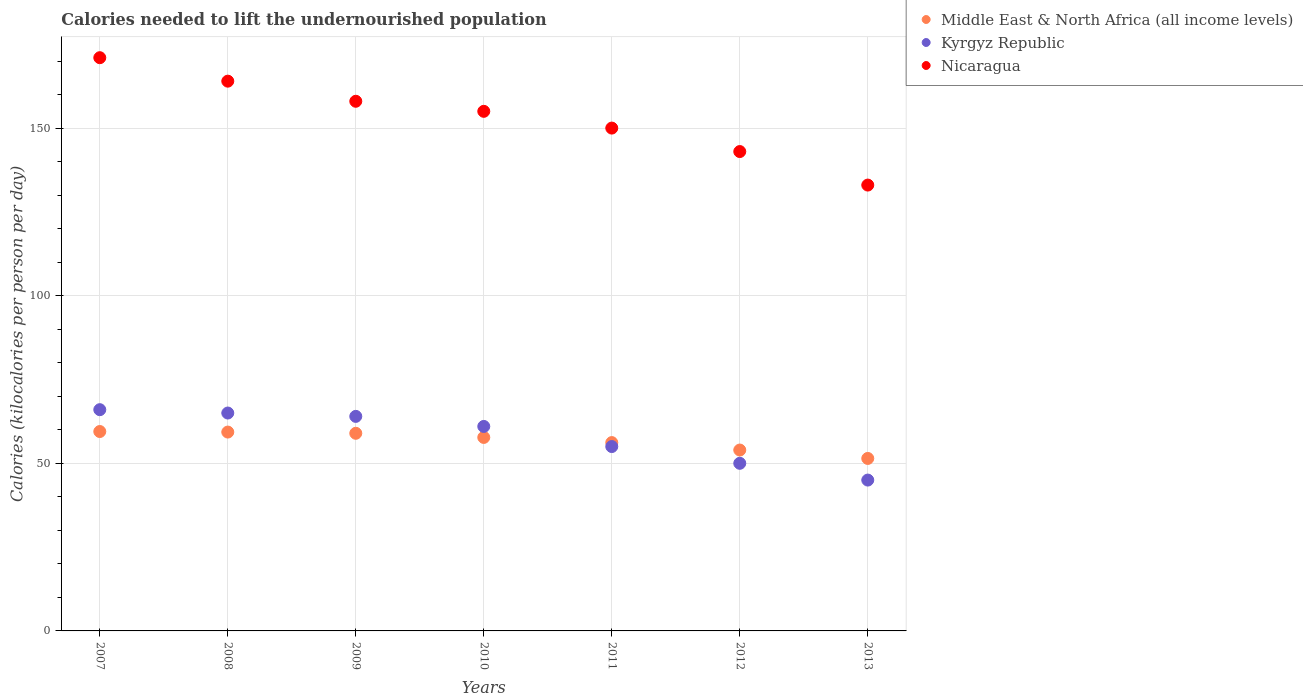How many different coloured dotlines are there?
Make the answer very short. 3. What is the total calories needed to lift the undernourished population in Middle East & North Africa (all income levels) in 2011?
Your answer should be very brief. 56.18. Across all years, what is the maximum total calories needed to lift the undernourished population in Kyrgyz Republic?
Give a very brief answer. 66. Across all years, what is the minimum total calories needed to lift the undernourished population in Nicaragua?
Offer a very short reply. 133. In which year was the total calories needed to lift the undernourished population in Kyrgyz Republic maximum?
Your answer should be very brief. 2007. What is the total total calories needed to lift the undernourished population in Nicaragua in the graph?
Your response must be concise. 1074. What is the difference between the total calories needed to lift the undernourished population in Middle East & North Africa (all income levels) in 2007 and that in 2010?
Ensure brevity in your answer.  1.76. What is the difference between the total calories needed to lift the undernourished population in Nicaragua in 2013 and the total calories needed to lift the undernourished population in Middle East & North Africa (all income levels) in 2010?
Provide a short and direct response. 75.28. What is the average total calories needed to lift the undernourished population in Kyrgyz Republic per year?
Your response must be concise. 58. In the year 2010, what is the difference between the total calories needed to lift the undernourished population in Nicaragua and total calories needed to lift the undernourished population in Kyrgyz Republic?
Provide a succinct answer. 94. In how many years, is the total calories needed to lift the undernourished population in Nicaragua greater than 130 kilocalories?
Provide a succinct answer. 7. What is the ratio of the total calories needed to lift the undernourished population in Nicaragua in 2010 to that in 2011?
Make the answer very short. 1.03. What is the difference between the highest and the lowest total calories needed to lift the undernourished population in Nicaragua?
Your answer should be compact. 38. In how many years, is the total calories needed to lift the undernourished population in Middle East & North Africa (all income levels) greater than the average total calories needed to lift the undernourished population in Middle East & North Africa (all income levels) taken over all years?
Offer a terse response. 4. Is the sum of the total calories needed to lift the undernourished population in Nicaragua in 2007 and 2009 greater than the maximum total calories needed to lift the undernourished population in Middle East & North Africa (all income levels) across all years?
Your answer should be very brief. Yes. Does the total calories needed to lift the undernourished population in Nicaragua monotonically increase over the years?
Provide a short and direct response. No. Is the total calories needed to lift the undernourished population in Kyrgyz Republic strictly less than the total calories needed to lift the undernourished population in Middle East & North Africa (all income levels) over the years?
Your answer should be very brief. No. How many years are there in the graph?
Offer a terse response. 7. Does the graph contain any zero values?
Offer a terse response. No. Does the graph contain grids?
Provide a short and direct response. Yes. Where does the legend appear in the graph?
Keep it short and to the point. Top right. What is the title of the graph?
Provide a short and direct response. Calories needed to lift the undernourished population. Does "Middle income" appear as one of the legend labels in the graph?
Provide a succinct answer. No. What is the label or title of the Y-axis?
Provide a short and direct response. Calories (kilocalories per person per day). What is the Calories (kilocalories per person per day) in Middle East & North Africa (all income levels) in 2007?
Ensure brevity in your answer.  59.48. What is the Calories (kilocalories per person per day) of Kyrgyz Republic in 2007?
Make the answer very short. 66. What is the Calories (kilocalories per person per day) in Nicaragua in 2007?
Ensure brevity in your answer.  171. What is the Calories (kilocalories per person per day) of Middle East & North Africa (all income levels) in 2008?
Provide a succinct answer. 59.32. What is the Calories (kilocalories per person per day) in Nicaragua in 2008?
Keep it short and to the point. 164. What is the Calories (kilocalories per person per day) of Middle East & North Africa (all income levels) in 2009?
Offer a terse response. 58.95. What is the Calories (kilocalories per person per day) in Nicaragua in 2009?
Your response must be concise. 158. What is the Calories (kilocalories per person per day) of Middle East & North Africa (all income levels) in 2010?
Make the answer very short. 57.72. What is the Calories (kilocalories per person per day) of Kyrgyz Republic in 2010?
Provide a succinct answer. 61. What is the Calories (kilocalories per person per day) in Nicaragua in 2010?
Make the answer very short. 155. What is the Calories (kilocalories per person per day) of Middle East & North Africa (all income levels) in 2011?
Your answer should be very brief. 56.18. What is the Calories (kilocalories per person per day) in Nicaragua in 2011?
Make the answer very short. 150. What is the Calories (kilocalories per person per day) of Middle East & North Africa (all income levels) in 2012?
Give a very brief answer. 53.96. What is the Calories (kilocalories per person per day) of Kyrgyz Republic in 2012?
Ensure brevity in your answer.  50. What is the Calories (kilocalories per person per day) of Nicaragua in 2012?
Keep it short and to the point. 143. What is the Calories (kilocalories per person per day) in Middle East & North Africa (all income levels) in 2013?
Give a very brief answer. 51.45. What is the Calories (kilocalories per person per day) of Nicaragua in 2013?
Your answer should be very brief. 133. Across all years, what is the maximum Calories (kilocalories per person per day) of Middle East & North Africa (all income levels)?
Ensure brevity in your answer.  59.48. Across all years, what is the maximum Calories (kilocalories per person per day) in Nicaragua?
Provide a succinct answer. 171. Across all years, what is the minimum Calories (kilocalories per person per day) of Middle East & North Africa (all income levels)?
Offer a terse response. 51.45. Across all years, what is the minimum Calories (kilocalories per person per day) of Kyrgyz Republic?
Provide a succinct answer. 45. Across all years, what is the minimum Calories (kilocalories per person per day) of Nicaragua?
Provide a succinct answer. 133. What is the total Calories (kilocalories per person per day) of Middle East & North Africa (all income levels) in the graph?
Offer a very short reply. 397.07. What is the total Calories (kilocalories per person per day) of Kyrgyz Republic in the graph?
Provide a succinct answer. 406. What is the total Calories (kilocalories per person per day) in Nicaragua in the graph?
Offer a very short reply. 1074. What is the difference between the Calories (kilocalories per person per day) of Middle East & North Africa (all income levels) in 2007 and that in 2008?
Ensure brevity in your answer.  0.16. What is the difference between the Calories (kilocalories per person per day) in Kyrgyz Republic in 2007 and that in 2008?
Offer a very short reply. 1. What is the difference between the Calories (kilocalories per person per day) of Middle East & North Africa (all income levels) in 2007 and that in 2009?
Your answer should be compact. 0.53. What is the difference between the Calories (kilocalories per person per day) of Nicaragua in 2007 and that in 2009?
Ensure brevity in your answer.  13. What is the difference between the Calories (kilocalories per person per day) of Middle East & North Africa (all income levels) in 2007 and that in 2010?
Make the answer very short. 1.76. What is the difference between the Calories (kilocalories per person per day) of Kyrgyz Republic in 2007 and that in 2010?
Keep it short and to the point. 5. What is the difference between the Calories (kilocalories per person per day) in Nicaragua in 2007 and that in 2010?
Make the answer very short. 16. What is the difference between the Calories (kilocalories per person per day) in Middle East & North Africa (all income levels) in 2007 and that in 2011?
Provide a short and direct response. 3.3. What is the difference between the Calories (kilocalories per person per day) in Nicaragua in 2007 and that in 2011?
Provide a succinct answer. 21. What is the difference between the Calories (kilocalories per person per day) of Middle East & North Africa (all income levels) in 2007 and that in 2012?
Offer a very short reply. 5.53. What is the difference between the Calories (kilocalories per person per day) in Middle East & North Africa (all income levels) in 2007 and that in 2013?
Your answer should be very brief. 8.03. What is the difference between the Calories (kilocalories per person per day) in Kyrgyz Republic in 2007 and that in 2013?
Offer a very short reply. 21. What is the difference between the Calories (kilocalories per person per day) of Nicaragua in 2007 and that in 2013?
Your response must be concise. 38. What is the difference between the Calories (kilocalories per person per day) of Middle East & North Africa (all income levels) in 2008 and that in 2009?
Give a very brief answer. 0.37. What is the difference between the Calories (kilocalories per person per day) of Kyrgyz Republic in 2008 and that in 2009?
Your answer should be very brief. 1. What is the difference between the Calories (kilocalories per person per day) in Nicaragua in 2008 and that in 2009?
Your response must be concise. 6. What is the difference between the Calories (kilocalories per person per day) of Middle East & North Africa (all income levels) in 2008 and that in 2010?
Your answer should be very brief. 1.6. What is the difference between the Calories (kilocalories per person per day) of Kyrgyz Republic in 2008 and that in 2010?
Your answer should be very brief. 4. What is the difference between the Calories (kilocalories per person per day) in Nicaragua in 2008 and that in 2010?
Offer a terse response. 9. What is the difference between the Calories (kilocalories per person per day) in Middle East & North Africa (all income levels) in 2008 and that in 2011?
Ensure brevity in your answer.  3.14. What is the difference between the Calories (kilocalories per person per day) in Nicaragua in 2008 and that in 2011?
Ensure brevity in your answer.  14. What is the difference between the Calories (kilocalories per person per day) in Middle East & North Africa (all income levels) in 2008 and that in 2012?
Offer a very short reply. 5.36. What is the difference between the Calories (kilocalories per person per day) of Kyrgyz Republic in 2008 and that in 2012?
Your answer should be very brief. 15. What is the difference between the Calories (kilocalories per person per day) of Nicaragua in 2008 and that in 2012?
Ensure brevity in your answer.  21. What is the difference between the Calories (kilocalories per person per day) in Middle East & North Africa (all income levels) in 2008 and that in 2013?
Provide a succinct answer. 7.87. What is the difference between the Calories (kilocalories per person per day) of Middle East & North Africa (all income levels) in 2009 and that in 2010?
Your answer should be compact. 1.23. What is the difference between the Calories (kilocalories per person per day) in Middle East & North Africa (all income levels) in 2009 and that in 2011?
Make the answer very short. 2.77. What is the difference between the Calories (kilocalories per person per day) of Middle East & North Africa (all income levels) in 2009 and that in 2012?
Give a very brief answer. 5. What is the difference between the Calories (kilocalories per person per day) in Middle East & North Africa (all income levels) in 2009 and that in 2013?
Your answer should be very brief. 7.5. What is the difference between the Calories (kilocalories per person per day) of Kyrgyz Republic in 2009 and that in 2013?
Your answer should be very brief. 19. What is the difference between the Calories (kilocalories per person per day) in Nicaragua in 2009 and that in 2013?
Provide a succinct answer. 25. What is the difference between the Calories (kilocalories per person per day) in Middle East & North Africa (all income levels) in 2010 and that in 2011?
Give a very brief answer. 1.54. What is the difference between the Calories (kilocalories per person per day) in Nicaragua in 2010 and that in 2011?
Offer a terse response. 5. What is the difference between the Calories (kilocalories per person per day) in Middle East & North Africa (all income levels) in 2010 and that in 2012?
Offer a very short reply. 3.76. What is the difference between the Calories (kilocalories per person per day) of Nicaragua in 2010 and that in 2012?
Offer a terse response. 12. What is the difference between the Calories (kilocalories per person per day) in Middle East & North Africa (all income levels) in 2010 and that in 2013?
Your answer should be compact. 6.27. What is the difference between the Calories (kilocalories per person per day) of Nicaragua in 2010 and that in 2013?
Your answer should be compact. 22. What is the difference between the Calories (kilocalories per person per day) of Middle East & North Africa (all income levels) in 2011 and that in 2012?
Your answer should be compact. 2.22. What is the difference between the Calories (kilocalories per person per day) in Middle East & North Africa (all income levels) in 2011 and that in 2013?
Ensure brevity in your answer.  4.73. What is the difference between the Calories (kilocalories per person per day) in Nicaragua in 2011 and that in 2013?
Provide a succinct answer. 17. What is the difference between the Calories (kilocalories per person per day) of Middle East & North Africa (all income levels) in 2012 and that in 2013?
Provide a succinct answer. 2.5. What is the difference between the Calories (kilocalories per person per day) of Kyrgyz Republic in 2012 and that in 2013?
Keep it short and to the point. 5. What is the difference between the Calories (kilocalories per person per day) in Nicaragua in 2012 and that in 2013?
Your response must be concise. 10. What is the difference between the Calories (kilocalories per person per day) in Middle East & North Africa (all income levels) in 2007 and the Calories (kilocalories per person per day) in Kyrgyz Republic in 2008?
Give a very brief answer. -5.52. What is the difference between the Calories (kilocalories per person per day) of Middle East & North Africa (all income levels) in 2007 and the Calories (kilocalories per person per day) of Nicaragua in 2008?
Your answer should be compact. -104.52. What is the difference between the Calories (kilocalories per person per day) in Kyrgyz Republic in 2007 and the Calories (kilocalories per person per day) in Nicaragua in 2008?
Your response must be concise. -98. What is the difference between the Calories (kilocalories per person per day) of Middle East & North Africa (all income levels) in 2007 and the Calories (kilocalories per person per day) of Kyrgyz Republic in 2009?
Offer a very short reply. -4.52. What is the difference between the Calories (kilocalories per person per day) in Middle East & North Africa (all income levels) in 2007 and the Calories (kilocalories per person per day) in Nicaragua in 2009?
Provide a succinct answer. -98.52. What is the difference between the Calories (kilocalories per person per day) of Kyrgyz Republic in 2007 and the Calories (kilocalories per person per day) of Nicaragua in 2009?
Your answer should be very brief. -92. What is the difference between the Calories (kilocalories per person per day) of Middle East & North Africa (all income levels) in 2007 and the Calories (kilocalories per person per day) of Kyrgyz Republic in 2010?
Offer a very short reply. -1.52. What is the difference between the Calories (kilocalories per person per day) of Middle East & North Africa (all income levels) in 2007 and the Calories (kilocalories per person per day) of Nicaragua in 2010?
Offer a terse response. -95.52. What is the difference between the Calories (kilocalories per person per day) in Kyrgyz Republic in 2007 and the Calories (kilocalories per person per day) in Nicaragua in 2010?
Your answer should be compact. -89. What is the difference between the Calories (kilocalories per person per day) in Middle East & North Africa (all income levels) in 2007 and the Calories (kilocalories per person per day) in Kyrgyz Republic in 2011?
Your answer should be compact. 4.48. What is the difference between the Calories (kilocalories per person per day) in Middle East & North Africa (all income levels) in 2007 and the Calories (kilocalories per person per day) in Nicaragua in 2011?
Your answer should be compact. -90.52. What is the difference between the Calories (kilocalories per person per day) in Kyrgyz Republic in 2007 and the Calories (kilocalories per person per day) in Nicaragua in 2011?
Give a very brief answer. -84. What is the difference between the Calories (kilocalories per person per day) of Middle East & North Africa (all income levels) in 2007 and the Calories (kilocalories per person per day) of Kyrgyz Republic in 2012?
Your answer should be compact. 9.48. What is the difference between the Calories (kilocalories per person per day) in Middle East & North Africa (all income levels) in 2007 and the Calories (kilocalories per person per day) in Nicaragua in 2012?
Your answer should be compact. -83.52. What is the difference between the Calories (kilocalories per person per day) of Kyrgyz Republic in 2007 and the Calories (kilocalories per person per day) of Nicaragua in 2012?
Your response must be concise. -77. What is the difference between the Calories (kilocalories per person per day) of Middle East & North Africa (all income levels) in 2007 and the Calories (kilocalories per person per day) of Kyrgyz Republic in 2013?
Your answer should be very brief. 14.48. What is the difference between the Calories (kilocalories per person per day) of Middle East & North Africa (all income levels) in 2007 and the Calories (kilocalories per person per day) of Nicaragua in 2013?
Make the answer very short. -73.52. What is the difference between the Calories (kilocalories per person per day) of Kyrgyz Republic in 2007 and the Calories (kilocalories per person per day) of Nicaragua in 2013?
Make the answer very short. -67. What is the difference between the Calories (kilocalories per person per day) of Middle East & North Africa (all income levels) in 2008 and the Calories (kilocalories per person per day) of Kyrgyz Republic in 2009?
Keep it short and to the point. -4.68. What is the difference between the Calories (kilocalories per person per day) of Middle East & North Africa (all income levels) in 2008 and the Calories (kilocalories per person per day) of Nicaragua in 2009?
Make the answer very short. -98.68. What is the difference between the Calories (kilocalories per person per day) in Kyrgyz Republic in 2008 and the Calories (kilocalories per person per day) in Nicaragua in 2009?
Provide a short and direct response. -93. What is the difference between the Calories (kilocalories per person per day) of Middle East & North Africa (all income levels) in 2008 and the Calories (kilocalories per person per day) of Kyrgyz Republic in 2010?
Make the answer very short. -1.68. What is the difference between the Calories (kilocalories per person per day) in Middle East & North Africa (all income levels) in 2008 and the Calories (kilocalories per person per day) in Nicaragua in 2010?
Provide a succinct answer. -95.68. What is the difference between the Calories (kilocalories per person per day) of Kyrgyz Republic in 2008 and the Calories (kilocalories per person per day) of Nicaragua in 2010?
Give a very brief answer. -90. What is the difference between the Calories (kilocalories per person per day) in Middle East & North Africa (all income levels) in 2008 and the Calories (kilocalories per person per day) in Kyrgyz Republic in 2011?
Make the answer very short. 4.32. What is the difference between the Calories (kilocalories per person per day) in Middle East & North Africa (all income levels) in 2008 and the Calories (kilocalories per person per day) in Nicaragua in 2011?
Offer a very short reply. -90.68. What is the difference between the Calories (kilocalories per person per day) of Kyrgyz Republic in 2008 and the Calories (kilocalories per person per day) of Nicaragua in 2011?
Provide a short and direct response. -85. What is the difference between the Calories (kilocalories per person per day) of Middle East & North Africa (all income levels) in 2008 and the Calories (kilocalories per person per day) of Kyrgyz Republic in 2012?
Make the answer very short. 9.32. What is the difference between the Calories (kilocalories per person per day) of Middle East & North Africa (all income levels) in 2008 and the Calories (kilocalories per person per day) of Nicaragua in 2012?
Make the answer very short. -83.68. What is the difference between the Calories (kilocalories per person per day) in Kyrgyz Republic in 2008 and the Calories (kilocalories per person per day) in Nicaragua in 2012?
Ensure brevity in your answer.  -78. What is the difference between the Calories (kilocalories per person per day) in Middle East & North Africa (all income levels) in 2008 and the Calories (kilocalories per person per day) in Kyrgyz Republic in 2013?
Provide a short and direct response. 14.32. What is the difference between the Calories (kilocalories per person per day) of Middle East & North Africa (all income levels) in 2008 and the Calories (kilocalories per person per day) of Nicaragua in 2013?
Make the answer very short. -73.68. What is the difference between the Calories (kilocalories per person per day) in Kyrgyz Republic in 2008 and the Calories (kilocalories per person per day) in Nicaragua in 2013?
Make the answer very short. -68. What is the difference between the Calories (kilocalories per person per day) of Middle East & North Africa (all income levels) in 2009 and the Calories (kilocalories per person per day) of Kyrgyz Republic in 2010?
Offer a terse response. -2.05. What is the difference between the Calories (kilocalories per person per day) in Middle East & North Africa (all income levels) in 2009 and the Calories (kilocalories per person per day) in Nicaragua in 2010?
Provide a short and direct response. -96.05. What is the difference between the Calories (kilocalories per person per day) in Kyrgyz Republic in 2009 and the Calories (kilocalories per person per day) in Nicaragua in 2010?
Keep it short and to the point. -91. What is the difference between the Calories (kilocalories per person per day) of Middle East & North Africa (all income levels) in 2009 and the Calories (kilocalories per person per day) of Kyrgyz Republic in 2011?
Give a very brief answer. 3.95. What is the difference between the Calories (kilocalories per person per day) of Middle East & North Africa (all income levels) in 2009 and the Calories (kilocalories per person per day) of Nicaragua in 2011?
Give a very brief answer. -91.05. What is the difference between the Calories (kilocalories per person per day) of Kyrgyz Republic in 2009 and the Calories (kilocalories per person per day) of Nicaragua in 2011?
Ensure brevity in your answer.  -86. What is the difference between the Calories (kilocalories per person per day) of Middle East & North Africa (all income levels) in 2009 and the Calories (kilocalories per person per day) of Kyrgyz Republic in 2012?
Offer a terse response. 8.95. What is the difference between the Calories (kilocalories per person per day) in Middle East & North Africa (all income levels) in 2009 and the Calories (kilocalories per person per day) in Nicaragua in 2012?
Provide a short and direct response. -84.05. What is the difference between the Calories (kilocalories per person per day) in Kyrgyz Republic in 2009 and the Calories (kilocalories per person per day) in Nicaragua in 2012?
Make the answer very short. -79. What is the difference between the Calories (kilocalories per person per day) of Middle East & North Africa (all income levels) in 2009 and the Calories (kilocalories per person per day) of Kyrgyz Republic in 2013?
Your response must be concise. 13.95. What is the difference between the Calories (kilocalories per person per day) of Middle East & North Africa (all income levels) in 2009 and the Calories (kilocalories per person per day) of Nicaragua in 2013?
Give a very brief answer. -74.05. What is the difference between the Calories (kilocalories per person per day) of Kyrgyz Republic in 2009 and the Calories (kilocalories per person per day) of Nicaragua in 2013?
Your answer should be compact. -69. What is the difference between the Calories (kilocalories per person per day) in Middle East & North Africa (all income levels) in 2010 and the Calories (kilocalories per person per day) in Kyrgyz Republic in 2011?
Your answer should be very brief. 2.72. What is the difference between the Calories (kilocalories per person per day) of Middle East & North Africa (all income levels) in 2010 and the Calories (kilocalories per person per day) of Nicaragua in 2011?
Provide a short and direct response. -92.28. What is the difference between the Calories (kilocalories per person per day) in Kyrgyz Republic in 2010 and the Calories (kilocalories per person per day) in Nicaragua in 2011?
Offer a very short reply. -89. What is the difference between the Calories (kilocalories per person per day) of Middle East & North Africa (all income levels) in 2010 and the Calories (kilocalories per person per day) of Kyrgyz Republic in 2012?
Provide a succinct answer. 7.72. What is the difference between the Calories (kilocalories per person per day) in Middle East & North Africa (all income levels) in 2010 and the Calories (kilocalories per person per day) in Nicaragua in 2012?
Give a very brief answer. -85.28. What is the difference between the Calories (kilocalories per person per day) of Kyrgyz Republic in 2010 and the Calories (kilocalories per person per day) of Nicaragua in 2012?
Make the answer very short. -82. What is the difference between the Calories (kilocalories per person per day) in Middle East & North Africa (all income levels) in 2010 and the Calories (kilocalories per person per day) in Kyrgyz Republic in 2013?
Offer a very short reply. 12.72. What is the difference between the Calories (kilocalories per person per day) of Middle East & North Africa (all income levels) in 2010 and the Calories (kilocalories per person per day) of Nicaragua in 2013?
Give a very brief answer. -75.28. What is the difference between the Calories (kilocalories per person per day) in Kyrgyz Republic in 2010 and the Calories (kilocalories per person per day) in Nicaragua in 2013?
Offer a terse response. -72. What is the difference between the Calories (kilocalories per person per day) of Middle East & North Africa (all income levels) in 2011 and the Calories (kilocalories per person per day) of Kyrgyz Republic in 2012?
Give a very brief answer. 6.18. What is the difference between the Calories (kilocalories per person per day) of Middle East & North Africa (all income levels) in 2011 and the Calories (kilocalories per person per day) of Nicaragua in 2012?
Make the answer very short. -86.82. What is the difference between the Calories (kilocalories per person per day) of Kyrgyz Republic in 2011 and the Calories (kilocalories per person per day) of Nicaragua in 2012?
Provide a succinct answer. -88. What is the difference between the Calories (kilocalories per person per day) of Middle East & North Africa (all income levels) in 2011 and the Calories (kilocalories per person per day) of Kyrgyz Republic in 2013?
Offer a very short reply. 11.18. What is the difference between the Calories (kilocalories per person per day) of Middle East & North Africa (all income levels) in 2011 and the Calories (kilocalories per person per day) of Nicaragua in 2013?
Keep it short and to the point. -76.82. What is the difference between the Calories (kilocalories per person per day) in Kyrgyz Republic in 2011 and the Calories (kilocalories per person per day) in Nicaragua in 2013?
Your response must be concise. -78. What is the difference between the Calories (kilocalories per person per day) in Middle East & North Africa (all income levels) in 2012 and the Calories (kilocalories per person per day) in Kyrgyz Republic in 2013?
Give a very brief answer. 8.96. What is the difference between the Calories (kilocalories per person per day) of Middle East & North Africa (all income levels) in 2012 and the Calories (kilocalories per person per day) of Nicaragua in 2013?
Make the answer very short. -79.04. What is the difference between the Calories (kilocalories per person per day) in Kyrgyz Republic in 2012 and the Calories (kilocalories per person per day) in Nicaragua in 2013?
Provide a succinct answer. -83. What is the average Calories (kilocalories per person per day) of Middle East & North Africa (all income levels) per year?
Your answer should be very brief. 56.72. What is the average Calories (kilocalories per person per day) in Nicaragua per year?
Ensure brevity in your answer.  153.43. In the year 2007, what is the difference between the Calories (kilocalories per person per day) in Middle East & North Africa (all income levels) and Calories (kilocalories per person per day) in Kyrgyz Republic?
Give a very brief answer. -6.52. In the year 2007, what is the difference between the Calories (kilocalories per person per day) of Middle East & North Africa (all income levels) and Calories (kilocalories per person per day) of Nicaragua?
Provide a succinct answer. -111.52. In the year 2007, what is the difference between the Calories (kilocalories per person per day) in Kyrgyz Republic and Calories (kilocalories per person per day) in Nicaragua?
Give a very brief answer. -105. In the year 2008, what is the difference between the Calories (kilocalories per person per day) in Middle East & North Africa (all income levels) and Calories (kilocalories per person per day) in Kyrgyz Republic?
Provide a succinct answer. -5.68. In the year 2008, what is the difference between the Calories (kilocalories per person per day) in Middle East & North Africa (all income levels) and Calories (kilocalories per person per day) in Nicaragua?
Provide a short and direct response. -104.68. In the year 2008, what is the difference between the Calories (kilocalories per person per day) of Kyrgyz Republic and Calories (kilocalories per person per day) of Nicaragua?
Provide a succinct answer. -99. In the year 2009, what is the difference between the Calories (kilocalories per person per day) of Middle East & North Africa (all income levels) and Calories (kilocalories per person per day) of Kyrgyz Republic?
Give a very brief answer. -5.05. In the year 2009, what is the difference between the Calories (kilocalories per person per day) of Middle East & North Africa (all income levels) and Calories (kilocalories per person per day) of Nicaragua?
Offer a very short reply. -99.05. In the year 2009, what is the difference between the Calories (kilocalories per person per day) of Kyrgyz Republic and Calories (kilocalories per person per day) of Nicaragua?
Keep it short and to the point. -94. In the year 2010, what is the difference between the Calories (kilocalories per person per day) in Middle East & North Africa (all income levels) and Calories (kilocalories per person per day) in Kyrgyz Republic?
Keep it short and to the point. -3.28. In the year 2010, what is the difference between the Calories (kilocalories per person per day) of Middle East & North Africa (all income levels) and Calories (kilocalories per person per day) of Nicaragua?
Make the answer very short. -97.28. In the year 2010, what is the difference between the Calories (kilocalories per person per day) in Kyrgyz Republic and Calories (kilocalories per person per day) in Nicaragua?
Your response must be concise. -94. In the year 2011, what is the difference between the Calories (kilocalories per person per day) in Middle East & North Africa (all income levels) and Calories (kilocalories per person per day) in Kyrgyz Republic?
Your response must be concise. 1.18. In the year 2011, what is the difference between the Calories (kilocalories per person per day) of Middle East & North Africa (all income levels) and Calories (kilocalories per person per day) of Nicaragua?
Make the answer very short. -93.82. In the year 2011, what is the difference between the Calories (kilocalories per person per day) of Kyrgyz Republic and Calories (kilocalories per person per day) of Nicaragua?
Offer a very short reply. -95. In the year 2012, what is the difference between the Calories (kilocalories per person per day) in Middle East & North Africa (all income levels) and Calories (kilocalories per person per day) in Kyrgyz Republic?
Your answer should be compact. 3.96. In the year 2012, what is the difference between the Calories (kilocalories per person per day) in Middle East & North Africa (all income levels) and Calories (kilocalories per person per day) in Nicaragua?
Offer a terse response. -89.04. In the year 2012, what is the difference between the Calories (kilocalories per person per day) of Kyrgyz Republic and Calories (kilocalories per person per day) of Nicaragua?
Your response must be concise. -93. In the year 2013, what is the difference between the Calories (kilocalories per person per day) in Middle East & North Africa (all income levels) and Calories (kilocalories per person per day) in Kyrgyz Republic?
Provide a short and direct response. 6.45. In the year 2013, what is the difference between the Calories (kilocalories per person per day) of Middle East & North Africa (all income levels) and Calories (kilocalories per person per day) of Nicaragua?
Provide a succinct answer. -81.55. In the year 2013, what is the difference between the Calories (kilocalories per person per day) of Kyrgyz Republic and Calories (kilocalories per person per day) of Nicaragua?
Give a very brief answer. -88. What is the ratio of the Calories (kilocalories per person per day) of Middle East & North Africa (all income levels) in 2007 to that in 2008?
Ensure brevity in your answer.  1. What is the ratio of the Calories (kilocalories per person per day) in Kyrgyz Republic in 2007 to that in 2008?
Give a very brief answer. 1.02. What is the ratio of the Calories (kilocalories per person per day) in Nicaragua in 2007 to that in 2008?
Your answer should be very brief. 1.04. What is the ratio of the Calories (kilocalories per person per day) of Kyrgyz Republic in 2007 to that in 2009?
Your answer should be very brief. 1.03. What is the ratio of the Calories (kilocalories per person per day) in Nicaragua in 2007 to that in 2009?
Provide a succinct answer. 1.08. What is the ratio of the Calories (kilocalories per person per day) of Middle East & North Africa (all income levels) in 2007 to that in 2010?
Offer a terse response. 1.03. What is the ratio of the Calories (kilocalories per person per day) of Kyrgyz Republic in 2007 to that in 2010?
Make the answer very short. 1.08. What is the ratio of the Calories (kilocalories per person per day) of Nicaragua in 2007 to that in 2010?
Provide a succinct answer. 1.1. What is the ratio of the Calories (kilocalories per person per day) of Middle East & North Africa (all income levels) in 2007 to that in 2011?
Ensure brevity in your answer.  1.06. What is the ratio of the Calories (kilocalories per person per day) of Kyrgyz Republic in 2007 to that in 2011?
Your answer should be very brief. 1.2. What is the ratio of the Calories (kilocalories per person per day) of Nicaragua in 2007 to that in 2011?
Give a very brief answer. 1.14. What is the ratio of the Calories (kilocalories per person per day) of Middle East & North Africa (all income levels) in 2007 to that in 2012?
Provide a short and direct response. 1.1. What is the ratio of the Calories (kilocalories per person per day) in Kyrgyz Republic in 2007 to that in 2012?
Your answer should be compact. 1.32. What is the ratio of the Calories (kilocalories per person per day) in Nicaragua in 2007 to that in 2012?
Ensure brevity in your answer.  1.2. What is the ratio of the Calories (kilocalories per person per day) of Middle East & North Africa (all income levels) in 2007 to that in 2013?
Ensure brevity in your answer.  1.16. What is the ratio of the Calories (kilocalories per person per day) of Kyrgyz Republic in 2007 to that in 2013?
Offer a very short reply. 1.47. What is the ratio of the Calories (kilocalories per person per day) of Nicaragua in 2007 to that in 2013?
Offer a terse response. 1.29. What is the ratio of the Calories (kilocalories per person per day) of Middle East & North Africa (all income levels) in 2008 to that in 2009?
Make the answer very short. 1.01. What is the ratio of the Calories (kilocalories per person per day) in Kyrgyz Republic in 2008 to that in 2009?
Ensure brevity in your answer.  1.02. What is the ratio of the Calories (kilocalories per person per day) of Nicaragua in 2008 to that in 2009?
Provide a succinct answer. 1.04. What is the ratio of the Calories (kilocalories per person per day) in Middle East & North Africa (all income levels) in 2008 to that in 2010?
Offer a terse response. 1.03. What is the ratio of the Calories (kilocalories per person per day) of Kyrgyz Republic in 2008 to that in 2010?
Provide a succinct answer. 1.07. What is the ratio of the Calories (kilocalories per person per day) of Nicaragua in 2008 to that in 2010?
Give a very brief answer. 1.06. What is the ratio of the Calories (kilocalories per person per day) in Middle East & North Africa (all income levels) in 2008 to that in 2011?
Your response must be concise. 1.06. What is the ratio of the Calories (kilocalories per person per day) in Kyrgyz Republic in 2008 to that in 2011?
Your answer should be compact. 1.18. What is the ratio of the Calories (kilocalories per person per day) of Nicaragua in 2008 to that in 2011?
Make the answer very short. 1.09. What is the ratio of the Calories (kilocalories per person per day) of Middle East & North Africa (all income levels) in 2008 to that in 2012?
Your answer should be very brief. 1.1. What is the ratio of the Calories (kilocalories per person per day) in Nicaragua in 2008 to that in 2012?
Provide a short and direct response. 1.15. What is the ratio of the Calories (kilocalories per person per day) in Middle East & North Africa (all income levels) in 2008 to that in 2013?
Keep it short and to the point. 1.15. What is the ratio of the Calories (kilocalories per person per day) of Kyrgyz Republic in 2008 to that in 2013?
Provide a succinct answer. 1.44. What is the ratio of the Calories (kilocalories per person per day) of Nicaragua in 2008 to that in 2013?
Give a very brief answer. 1.23. What is the ratio of the Calories (kilocalories per person per day) in Middle East & North Africa (all income levels) in 2009 to that in 2010?
Ensure brevity in your answer.  1.02. What is the ratio of the Calories (kilocalories per person per day) in Kyrgyz Republic in 2009 to that in 2010?
Your answer should be compact. 1.05. What is the ratio of the Calories (kilocalories per person per day) in Nicaragua in 2009 to that in 2010?
Offer a very short reply. 1.02. What is the ratio of the Calories (kilocalories per person per day) of Middle East & North Africa (all income levels) in 2009 to that in 2011?
Offer a very short reply. 1.05. What is the ratio of the Calories (kilocalories per person per day) in Kyrgyz Republic in 2009 to that in 2011?
Make the answer very short. 1.16. What is the ratio of the Calories (kilocalories per person per day) of Nicaragua in 2009 to that in 2011?
Offer a very short reply. 1.05. What is the ratio of the Calories (kilocalories per person per day) in Middle East & North Africa (all income levels) in 2009 to that in 2012?
Provide a succinct answer. 1.09. What is the ratio of the Calories (kilocalories per person per day) in Kyrgyz Republic in 2009 to that in 2012?
Offer a terse response. 1.28. What is the ratio of the Calories (kilocalories per person per day) in Nicaragua in 2009 to that in 2012?
Offer a terse response. 1.1. What is the ratio of the Calories (kilocalories per person per day) in Middle East & North Africa (all income levels) in 2009 to that in 2013?
Your response must be concise. 1.15. What is the ratio of the Calories (kilocalories per person per day) in Kyrgyz Republic in 2009 to that in 2013?
Your answer should be very brief. 1.42. What is the ratio of the Calories (kilocalories per person per day) of Nicaragua in 2009 to that in 2013?
Offer a terse response. 1.19. What is the ratio of the Calories (kilocalories per person per day) in Middle East & North Africa (all income levels) in 2010 to that in 2011?
Your answer should be compact. 1.03. What is the ratio of the Calories (kilocalories per person per day) of Kyrgyz Republic in 2010 to that in 2011?
Provide a short and direct response. 1.11. What is the ratio of the Calories (kilocalories per person per day) in Middle East & North Africa (all income levels) in 2010 to that in 2012?
Offer a very short reply. 1.07. What is the ratio of the Calories (kilocalories per person per day) of Kyrgyz Republic in 2010 to that in 2012?
Ensure brevity in your answer.  1.22. What is the ratio of the Calories (kilocalories per person per day) in Nicaragua in 2010 to that in 2012?
Your answer should be very brief. 1.08. What is the ratio of the Calories (kilocalories per person per day) of Middle East & North Africa (all income levels) in 2010 to that in 2013?
Offer a terse response. 1.12. What is the ratio of the Calories (kilocalories per person per day) in Kyrgyz Republic in 2010 to that in 2013?
Keep it short and to the point. 1.36. What is the ratio of the Calories (kilocalories per person per day) of Nicaragua in 2010 to that in 2013?
Your answer should be compact. 1.17. What is the ratio of the Calories (kilocalories per person per day) of Middle East & North Africa (all income levels) in 2011 to that in 2012?
Offer a terse response. 1.04. What is the ratio of the Calories (kilocalories per person per day) in Kyrgyz Republic in 2011 to that in 2012?
Make the answer very short. 1.1. What is the ratio of the Calories (kilocalories per person per day) in Nicaragua in 2011 to that in 2012?
Give a very brief answer. 1.05. What is the ratio of the Calories (kilocalories per person per day) in Middle East & North Africa (all income levels) in 2011 to that in 2013?
Keep it short and to the point. 1.09. What is the ratio of the Calories (kilocalories per person per day) in Kyrgyz Republic in 2011 to that in 2013?
Your answer should be very brief. 1.22. What is the ratio of the Calories (kilocalories per person per day) in Nicaragua in 2011 to that in 2013?
Provide a succinct answer. 1.13. What is the ratio of the Calories (kilocalories per person per day) of Middle East & North Africa (all income levels) in 2012 to that in 2013?
Give a very brief answer. 1.05. What is the ratio of the Calories (kilocalories per person per day) of Kyrgyz Republic in 2012 to that in 2013?
Offer a terse response. 1.11. What is the ratio of the Calories (kilocalories per person per day) of Nicaragua in 2012 to that in 2013?
Your response must be concise. 1.08. What is the difference between the highest and the second highest Calories (kilocalories per person per day) in Middle East & North Africa (all income levels)?
Make the answer very short. 0.16. What is the difference between the highest and the second highest Calories (kilocalories per person per day) in Kyrgyz Republic?
Your answer should be compact. 1. What is the difference between the highest and the second highest Calories (kilocalories per person per day) of Nicaragua?
Offer a terse response. 7. What is the difference between the highest and the lowest Calories (kilocalories per person per day) of Middle East & North Africa (all income levels)?
Keep it short and to the point. 8.03. What is the difference between the highest and the lowest Calories (kilocalories per person per day) in Kyrgyz Republic?
Make the answer very short. 21. What is the difference between the highest and the lowest Calories (kilocalories per person per day) in Nicaragua?
Ensure brevity in your answer.  38. 